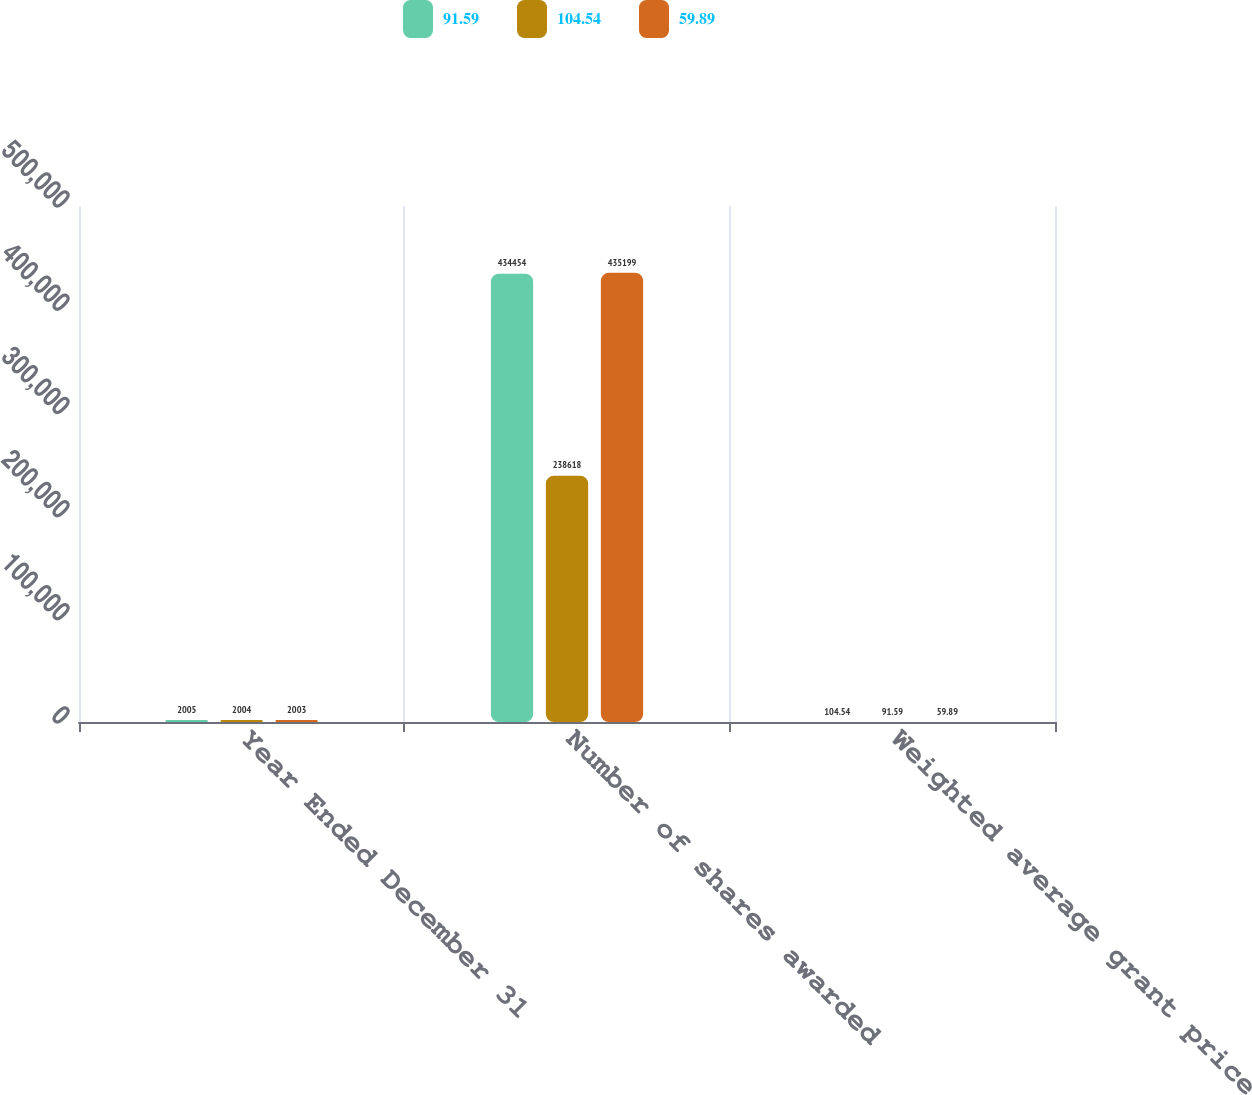<chart> <loc_0><loc_0><loc_500><loc_500><stacked_bar_chart><ecel><fcel>Year Ended December 31<fcel>Number of shares awarded<fcel>Weighted average grant price<nl><fcel>91.59<fcel>2005<fcel>434454<fcel>104.54<nl><fcel>104.54<fcel>2004<fcel>238618<fcel>91.59<nl><fcel>59.89<fcel>2003<fcel>435199<fcel>59.89<nl></chart> 